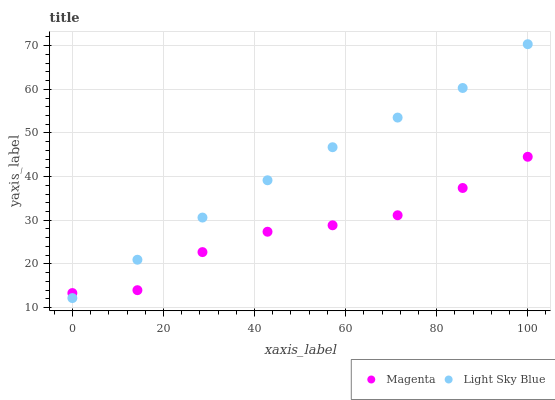Does Magenta have the minimum area under the curve?
Answer yes or no. Yes. Does Light Sky Blue have the maximum area under the curve?
Answer yes or no. Yes. Does Light Sky Blue have the minimum area under the curve?
Answer yes or no. No. Is Light Sky Blue the smoothest?
Answer yes or no. Yes. Is Magenta the roughest?
Answer yes or no. Yes. Is Light Sky Blue the roughest?
Answer yes or no. No. Does Light Sky Blue have the lowest value?
Answer yes or no. Yes. Does Light Sky Blue have the highest value?
Answer yes or no. Yes. Does Light Sky Blue intersect Magenta?
Answer yes or no. Yes. Is Light Sky Blue less than Magenta?
Answer yes or no. No. Is Light Sky Blue greater than Magenta?
Answer yes or no. No. 